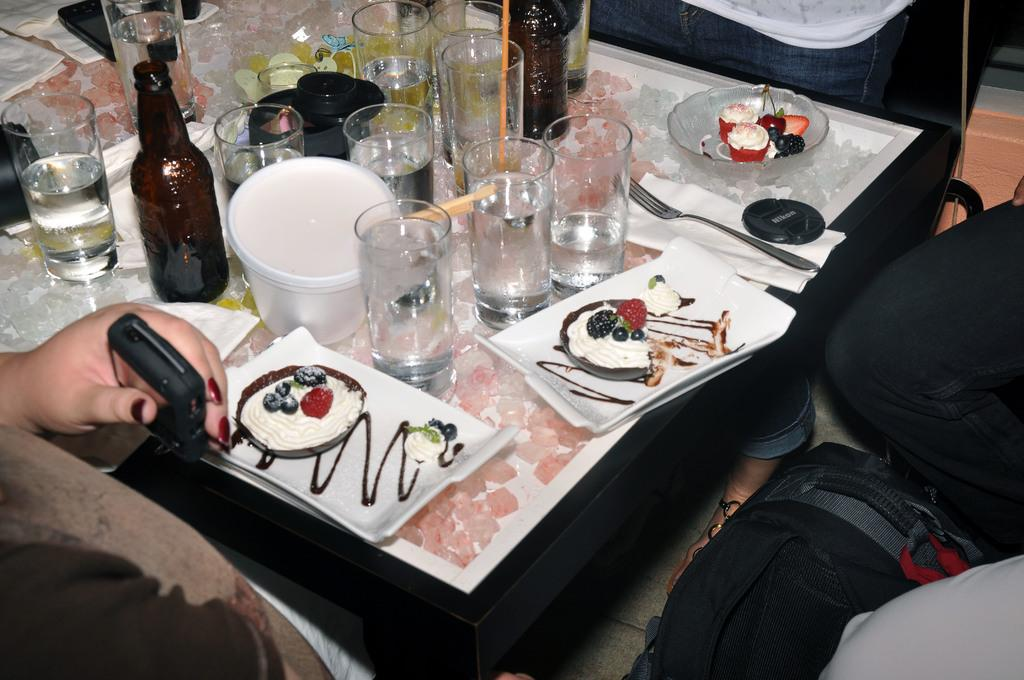What is on the plate that is visible in the image? There is a plate of food items in the image. What type of containers can be seen in the image? There are glasses and glass bottles visible in the image. What utensil is present in the image? There is a fork in the image. Where are the objects located in the image? The objects are on a table. What else can be seen on the left side of the image? There is a hand of a person on the left side of the image. What is on the right side of the image? There are bags on the right side of the image. What type of doctor is attending the party in the image? There is no party or doctor present in the image; it features a plate of food items, glasses, a fork, glass bottles, a hand, and bags on a table. 